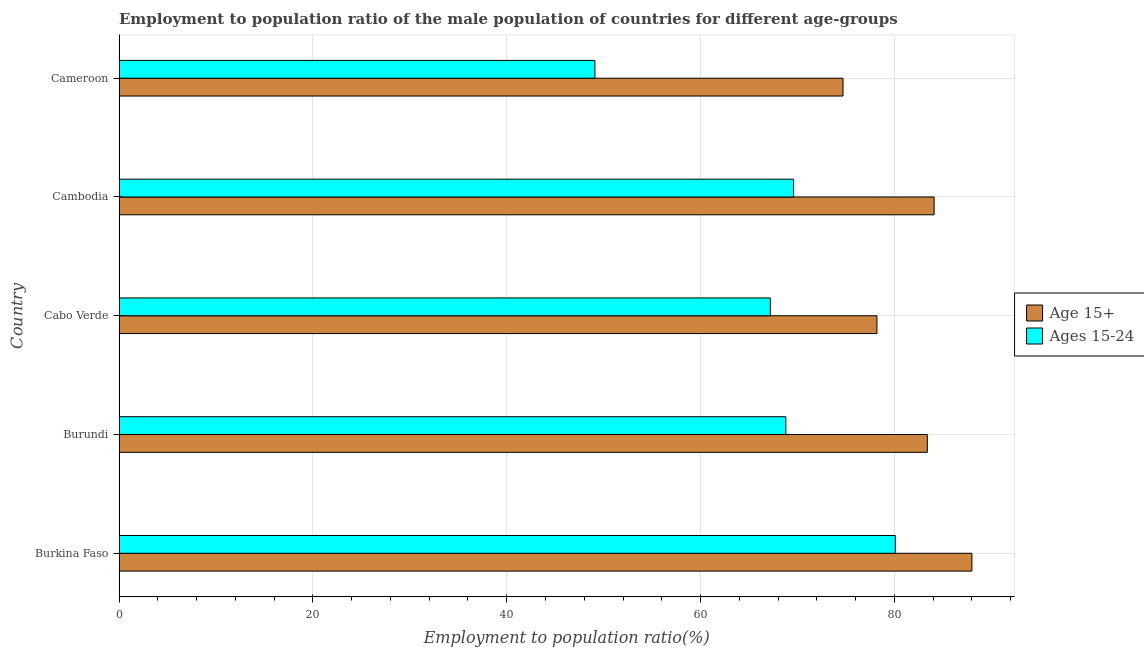How many different coloured bars are there?
Keep it short and to the point. 2. How many groups of bars are there?
Offer a terse response. 5. Are the number of bars per tick equal to the number of legend labels?
Your answer should be compact. Yes. How many bars are there on the 1st tick from the bottom?
Offer a terse response. 2. What is the label of the 2nd group of bars from the top?
Your response must be concise. Cambodia. In how many cases, is the number of bars for a given country not equal to the number of legend labels?
Provide a succinct answer. 0. What is the employment to population ratio(age 15-24) in Cameroon?
Ensure brevity in your answer.  49.1. Across all countries, what is the maximum employment to population ratio(age 15-24)?
Make the answer very short. 80.1. Across all countries, what is the minimum employment to population ratio(age 15-24)?
Provide a succinct answer. 49.1. In which country was the employment to population ratio(age 15-24) maximum?
Your answer should be very brief. Burkina Faso. In which country was the employment to population ratio(age 15+) minimum?
Provide a short and direct response. Cameroon. What is the total employment to population ratio(age 15+) in the graph?
Give a very brief answer. 408.4. What is the difference between the employment to population ratio(age 15-24) in Burundi and the employment to population ratio(age 15+) in Cabo Verde?
Your response must be concise. -9.4. What is the average employment to population ratio(age 15+) per country?
Your answer should be very brief. 81.68. What is the difference between the employment to population ratio(age 15-24) and employment to population ratio(age 15+) in Cameroon?
Your answer should be very brief. -25.6. In how many countries, is the employment to population ratio(age 15+) greater than 84 %?
Give a very brief answer. 2. What is the ratio of the employment to population ratio(age 15+) in Burkina Faso to that in Cabo Verde?
Provide a succinct answer. 1.12. Is the employment to population ratio(age 15+) in Burkina Faso less than that in Cabo Verde?
Provide a succinct answer. No. Is the difference between the employment to population ratio(age 15+) in Cabo Verde and Cambodia greater than the difference between the employment to population ratio(age 15-24) in Cabo Verde and Cambodia?
Offer a terse response. No. What is the difference between the highest and the lowest employment to population ratio(age 15-24)?
Your answer should be very brief. 31. In how many countries, is the employment to population ratio(age 15-24) greater than the average employment to population ratio(age 15-24) taken over all countries?
Make the answer very short. 4. What does the 1st bar from the top in Cameroon represents?
Provide a succinct answer. Ages 15-24. What does the 2nd bar from the bottom in Cameroon represents?
Keep it short and to the point. Ages 15-24. How many bars are there?
Provide a succinct answer. 10. How many countries are there in the graph?
Provide a short and direct response. 5. Are the values on the major ticks of X-axis written in scientific E-notation?
Your answer should be very brief. No. Does the graph contain any zero values?
Ensure brevity in your answer.  No. Where does the legend appear in the graph?
Your answer should be very brief. Center right. What is the title of the graph?
Your answer should be compact. Employment to population ratio of the male population of countries for different age-groups. What is the Employment to population ratio(%) in Age 15+ in Burkina Faso?
Offer a terse response. 88. What is the Employment to population ratio(%) of Ages 15-24 in Burkina Faso?
Provide a succinct answer. 80.1. What is the Employment to population ratio(%) in Age 15+ in Burundi?
Give a very brief answer. 83.4. What is the Employment to population ratio(%) in Ages 15-24 in Burundi?
Provide a short and direct response. 68.8. What is the Employment to population ratio(%) in Age 15+ in Cabo Verde?
Keep it short and to the point. 78.2. What is the Employment to population ratio(%) in Ages 15-24 in Cabo Verde?
Your answer should be compact. 67.2. What is the Employment to population ratio(%) of Age 15+ in Cambodia?
Your answer should be compact. 84.1. What is the Employment to population ratio(%) of Ages 15-24 in Cambodia?
Keep it short and to the point. 69.6. What is the Employment to population ratio(%) in Age 15+ in Cameroon?
Your answer should be very brief. 74.7. What is the Employment to population ratio(%) in Ages 15-24 in Cameroon?
Ensure brevity in your answer.  49.1. Across all countries, what is the maximum Employment to population ratio(%) in Ages 15-24?
Provide a short and direct response. 80.1. Across all countries, what is the minimum Employment to population ratio(%) in Age 15+?
Provide a short and direct response. 74.7. Across all countries, what is the minimum Employment to population ratio(%) in Ages 15-24?
Your response must be concise. 49.1. What is the total Employment to population ratio(%) in Age 15+ in the graph?
Offer a terse response. 408.4. What is the total Employment to population ratio(%) of Ages 15-24 in the graph?
Ensure brevity in your answer.  334.8. What is the difference between the Employment to population ratio(%) of Age 15+ in Burkina Faso and that in Burundi?
Ensure brevity in your answer.  4.6. What is the difference between the Employment to population ratio(%) in Ages 15-24 in Burkina Faso and that in Burundi?
Ensure brevity in your answer.  11.3. What is the difference between the Employment to population ratio(%) in Age 15+ in Burkina Faso and that in Cabo Verde?
Keep it short and to the point. 9.8. What is the difference between the Employment to population ratio(%) of Age 15+ in Burkina Faso and that in Cambodia?
Give a very brief answer. 3.9. What is the difference between the Employment to population ratio(%) of Age 15+ in Burkina Faso and that in Cameroon?
Offer a very short reply. 13.3. What is the difference between the Employment to population ratio(%) in Ages 15-24 in Burkina Faso and that in Cameroon?
Keep it short and to the point. 31. What is the difference between the Employment to population ratio(%) of Age 15+ in Burundi and that in Cabo Verde?
Your answer should be compact. 5.2. What is the difference between the Employment to population ratio(%) in Age 15+ in Burundi and that in Cambodia?
Offer a very short reply. -0.7. What is the difference between the Employment to population ratio(%) in Ages 15-24 in Burundi and that in Cambodia?
Provide a succinct answer. -0.8. What is the difference between the Employment to population ratio(%) in Age 15+ in Burundi and that in Cameroon?
Make the answer very short. 8.7. What is the difference between the Employment to population ratio(%) in Ages 15-24 in Burundi and that in Cameroon?
Offer a terse response. 19.7. What is the difference between the Employment to population ratio(%) of Ages 15-24 in Cabo Verde and that in Cambodia?
Make the answer very short. -2.4. What is the difference between the Employment to population ratio(%) in Age 15+ in Cabo Verde and that in Cameroon?
Give a very brief answer. 3.5. What is the difference between the Employment to population ratio(%) of Age 15+ in Cambodia and that in Cameroon?
Offer a very short reply. 9.4. What is the difference between the Employment to population ratio(%) of Ages 15-24 in Cambodia and that in Cameroon?
Keep it short and to the point. 20.5. What is the difference between the Employment to population ratio(%) of Age 15+ in Burkina Faso and the Employment to population ratio(%) of Ages 15-24 in Burundi?
Give a very brief answer. 19.2. What is the difference between the Employment to population ratio(%) of Age 15+ in Burkina Faso and the Employment to population ratio(%) of Ages 15-24 in Cabo Verde?
Provide a succinct answer. 20.8. What is the difference between the Employment to population ratio(%) in Age 15+ in Burkina Faso and the Employment to population ratio(%) in Ages 15-24 in Cameroon?
Offer a terse response. 38.9. What is the difference between the Employment to population ratio(%) in Age 15+ in Burundi and the Employment to population ratio(%) in Ages 15-24 in Cabo Verde?
Offer a very short reply. 16.2. What is the difference between the Employment to population ratio(%) in Age 15+ in Burundi and the Employment to population ratio(%) in Ages 15-24 in Cambodia?
Provide a short and direct response. 13.8. What is the difference between the Employment to population ratio(%) in Age 15+ in Burundi and the Employment to population ratio(%) in Ages 15-24 in Cameroon?
Offer a terse response. 34.3. What is the difference between the Employment to population ratio(%) of Age 15+ in Cabo Verde and the Employment to population ratio(%) of Ages 15-24 in Cambodia?
Ensure brevity in your answer.  8.6. What is the difference between the Employment to population ratio(%) in Age 15+ in Cabo Verde and the Employment to population ratio(%) in Ages 15-24 in Cameroon?
Provide a short and direct response. 29.1. What is the difference between the Employment to population ratio(%) of Age 15+ in Cambodia and the Employment to population ratio(%) of Ages 15-24 in Cameroon?
Give a very brief answer. 35. What is the average Employment to population ratio(%) of Age 15+ per country?
Make the answer very short. 81.68. What is the average Employment to population ratio(%) in Ages 15-24 per country?
Your response must be concise. 66.96. What is the difference between the Employment to population ratio(%) in Age 15+ and Employment to population ratio(%) in Ages 15-24 in Burundi?
Provide a short and direct response. 14.6. What is the difference between the Employment to population ratio(%) of Age 15+ and Employment to population ratio(%) of Ages 15-24 in Cabo Verde?
Keep it short and to the point. 11. What is the difference between the Employment to population ratio(%) of Age 15+ and Employment to population ratio(%) of Ages 15-24 in Cameroon?
Offer a very short reply. 25.6. What is the ratio of the Employment to population ratio(%) of Age 15+ in Burkina Faso to that in Burundi?
Your response must be concise. 1.06. What is the ratio of the Employment to population ratio(%) in Ages 15-24 in Burkina Faso to that in Burundi?
Your response must be concise. 1.16. What is the ratio of the Employment to population ratio(%) of Age 15+ in Burkina Faso to that in Cabo Verde?
Your answer should be compact. 1.13. What is the ratio of the Employment to population ratio(%) in Ages 15-24 in Burkina Faso to that in Cabo Verde?
Offer a terse response. 1.19. What is the ratio of the Employment to population ratio(%) of Age 15+ in Burkina Faso to that in Cambodia?
Offer a very short reply. 1.05. What is the ratio of the Employment to population ratio(%) in Ages 15-24 in Burkina Faso to that in Cambodia?
Your response must be concise. 1.15. What is the ratio of the Employment to population ratio(%) of Age 15+ in Burkina Faso to that in Cameroon?
Offer a very short reply. 1.18. What is the ratio of the Employment to population ratio(%) in Ages 15-24 in Burkina Faso to that in Cameroon?
Provide a succinct answer. 1.63. What is the ratio of the Employment to population ratio(%) of Age 15+ in Burundi to that in Cabo Verde?
Provide a short and direct response. 1.07. What is the ratio of the Employment to population ratio(%) of Ages 15-24 in Burundi to that in Cabo Verde?
Give a very brief answer. 1.02. What is the ratio of the Employment to population ratio(%) of Age 15+ in Burundi to that in Cambodia?
Keep it short and to the point. 0.99. What is the ratio of the Employment to population ratio(%) of Age 15+ in Burundi to that in Cameroon?
Offer a very short reply. 1.12. What is the ratio of the Employment to population ratio(%) in Ages 15-24 in Burundi to that in Cameroon?
Offer a very short reply. 1.4. What is the ratio of the Employment to population ratio(%) of Age 15+ in Cabo Verde to that in Cambodia?
Keep it short and to the point. 0.93. What is the ratio of the Employment to population ratio(%) in Ages 15-24 in Cabo Verde to that in Cambodia?
Ensure brevity in your answer.  0.97. What is the ratio of the Employment to population ratio(%) of Age 15+ in Cabo Verde to that in Cameroon?
Keep it short and to the point. 1.05. What is the ratio of the Employment to population ratio(%) of Ages 15-24 in Cabo Verde to that in Cameroon?
Provide a short and direct response. 1.37. What is the ratio of the Employment to population ratio(%) of Age 15+ in Cambodia to that in Cameroon?
Your response must be concise. 1.13. What is the ratio of the Employment to population ratio(%) in Ages 15-24 in Cambodia to that in Cameroon?
Give a very brief answer. 1.42. What is the difference between the highest and the second highest Employment to population ratio(%) of Age 15+?
Ensure brevity in your answer.  3.9. What is the difference between the highest and the second highest Employment to population ratio(%) in Ages 15-24?
Ensure brevity in your answer.  10.5. 